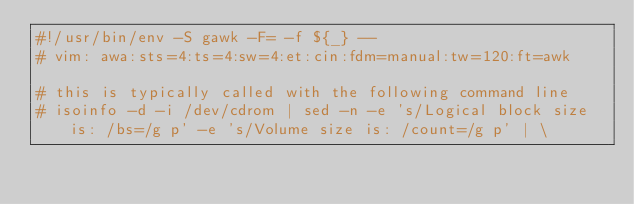<code> <loc_0><loc_0><loc_500><loc_500><_Awk_>#!/usr/bin/env -S gawk -F= -f ${_} --
# vim: awa:sts=4:ts=4:sw=4:et:cin:fdm=manual:tw=120:ft=awk

# this is typically called with the following command line
# isoinfo -d -i /dev/cdrom | sed -n -e 's/Logical block size is: /bs=/g p' -e 's/Volume size is: /count=/g p' | \</code> 